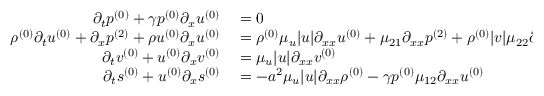Convert formula to latex. <formula><loc_0><loc_0><loc_500><loc_500>\begin{array} { r l } { \partial _ { t } { p ^ { ( 0 ) } } + \gamma { p ^ { ( 0 ) } } \partial _ { x } { u ^ { ( 0 ) } } } & = 0 } \\ { { \rho ^ { ( 0 ) } } \partial _ { t } { u ^ { ( 0 ) } } + \partial _ { x } { p ^ { ( 2 ) } } + { \rho u ^ { ( 0 ) } } \partial _ { x } { u ^ { ( 0 ) } } } & = { \rho ^ { ( 0 ) } } \mu _ { u } | u | \partial _ { x x } { u ^ { ( 0 ) } } + \mu _ { 2 1 } \partial _ { x x } { p ^ { ( 2 ) } } + { \rho ^ { ( 0 ) } } | v | \mu _ { 2 2 } \partial _ { x x } { u ^ { ( 0 ) } } } \\ { \partial _ { t } { v ^ { ( 0 ) } } + { u ^ { ( 0 ) } } \partial _ { x } { v ^ { ( 0 ) } } } & = \mu _ { u } | u | \partial _ { x x } { v ^ { ( 0 ) } } } \\ { \partial _ { t } { s ^ { ( 0 ) } } + { u ^ { ( 0 ) } } \partial _ { x } { s ^ { ( 0 ) } } } & = - a ^ { 2 } \mu _ { u } | u | \partial _ { x x } { \rho ^ { ( 0 ) } } - \gamma { p ^ { ( 0 ) } } \mu _ { 1 2 } \partial _ { x x } { u ^ { ( 0 ) } } } \end{array}</formula> 